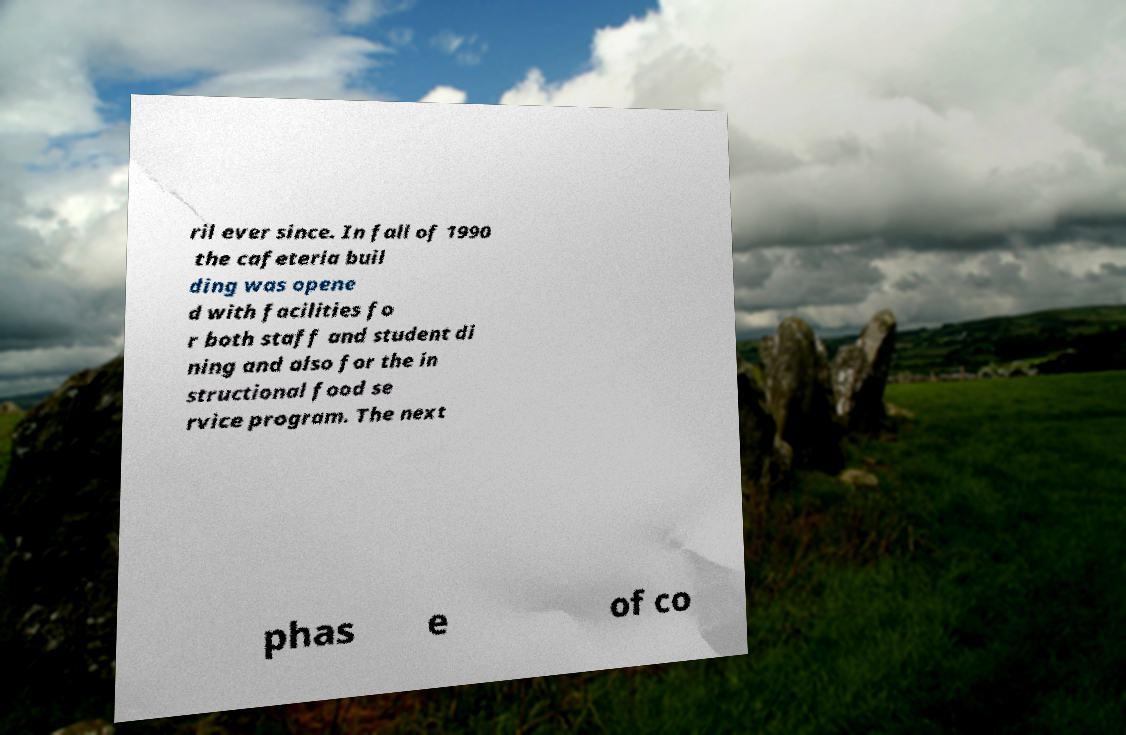Could you extract and type out the text from this image? ril ever since. In fall of 1990 the cafeteria buil ding was opene d with facilities fo r both staff and student di ning and also for the in structional food se rvice program. The next phas e of co 